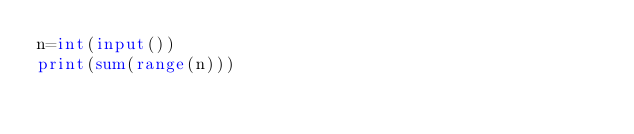<code> <loc_0><loc_0><loc_500><loc_500><_Python_>n=int(input())
print(sum(range(n)))</code> 